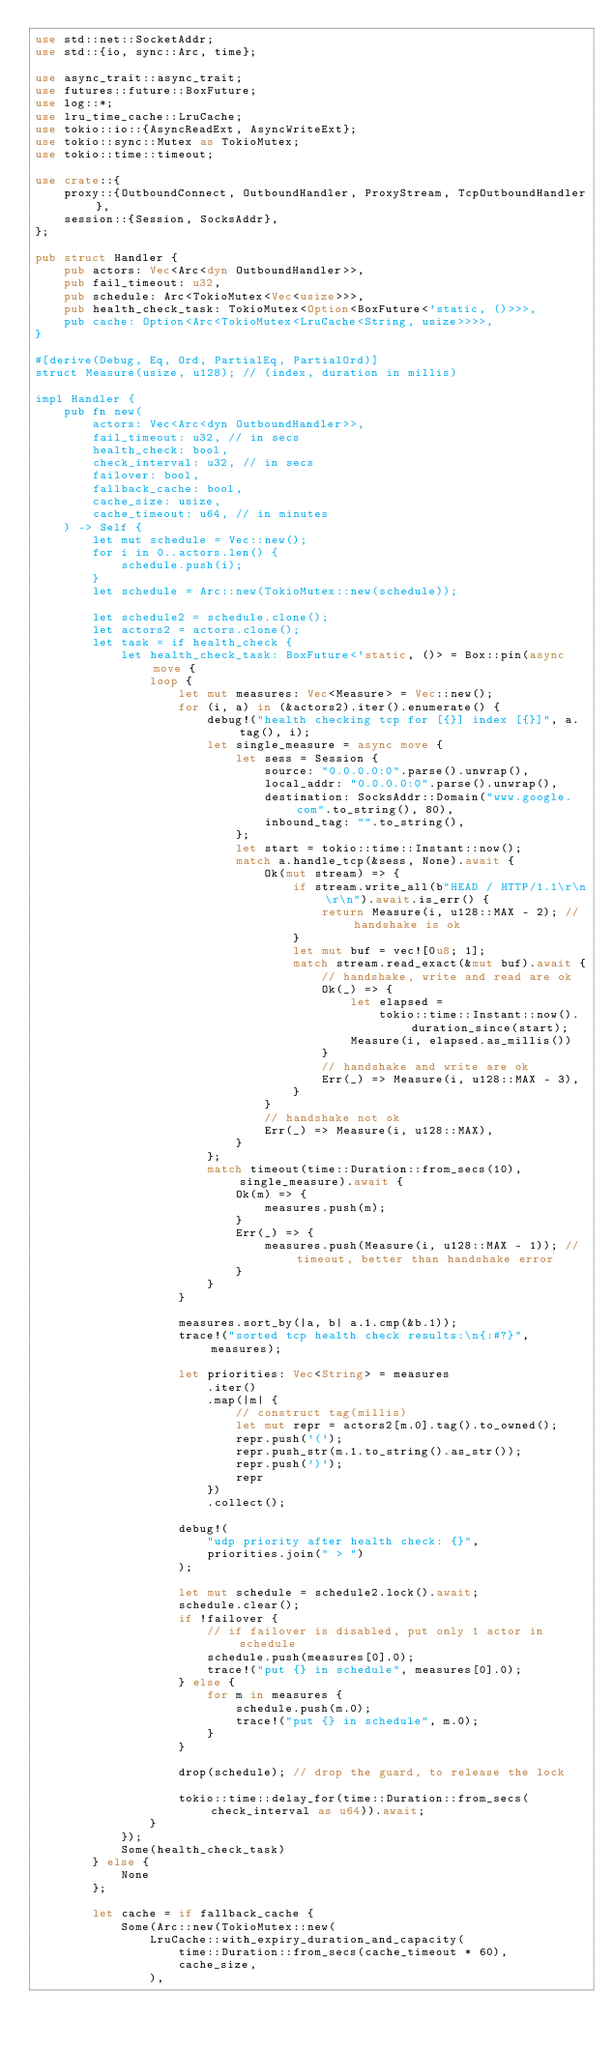Convert code to text. <code><loc_0><loc_0><loc_500><loc_500><_Rust_>use std::net::SocketAddr;
use std::{io, sync::Arc, time};

use async_trait::async_trait;
use futures::future::BoxFuture;
use log::*;
use lru_time_cache::LruCache;
use tokio::io::{AsyncReadExt, AsyncWriteExt};
use tokio::sync::Mutex as TokioMutex;
use tokio::time::timeout;

use crate::{
    proxy::{OutboundConnect, OutboundHandler, ProxyStream, TcpOutboundHandler},
    session::{Session, SocksAddr},
};

pub struct Handler {
    pub actors: Vec<Arc<dyn OutboundHandler>>,
    pub fail_timeout: u32,
    pub schedule: Arc<TokioMutex<Vec<usize>>>,
    pub health_check_task: TokioMutex<Option<BoxFuture<'static, ()>>>,
    pub cache: Option<Arc<TokioMutex<LruCache<String, usize>>>>,
}

#[derive(Debug, Eq, Ord, PartialEq, PartialOrd)]
struct Measure(usize, u128); // (index, duration in millis)

impl Handler {
    pub fn new(
        actors: Vec<Arc<dyn OutboundHandler>>,
        fail_timeout: u32, // in secs
        health_check: bool,
        check_interval: u32, // in secs
        failover: bool,
        fallback_cache: bool,
        cache_size: usize,
        cache_timeout: u64, // in minutes
    ) -> Self {
        let mut schedule = Vec::new();
        for i in 0..actors.len() {
            schedule.push(i);
        }
        let schedule = Arc::new(TokioMutex::new(schedule));

        let schedule2 = schedule.clone();
        let actors2 = actors.clone();
        let task = if health_check {
            let health_check_task: BoxFuture<'static, ()> = Box::pin(async move {
                loop {
                    let mut measures: Vec<Measure> = Vec::new();
                    for (i, a) in (&actors2).iter().enumerate() {
                        debug!("health checking tcp for [{}] index [{}]", a.tag(), i);
                        let single_measure = async move {
                            let sess = Session {
                                source: "0.0.0.0:0".parse().unwrap(),
                                local_addr: "0.0.0.0:0".parse().unwrap(),
                                destination: SocksAddr::Domain("www.google.com".to_string(), 80),
                                inbound_tag: "".to_string(),
                            };
                            let start = tokio::time::Instant::now();
                            match a.handle_tcp(&sess, None).await {
                                Ok(mut stream) => {
                                    if stream.write_all(b"HEAD / HTTP/1.1\r\n\r\n").await.is_err() {
                                        return Measure(i, u128::MAX - 2); // handshake is ok
                                    }
                                    let mut buf = vec![0u8; 1];
                                    match stream.read_exact(&mut buf).await {
                                        // handshake, write and read are ok
                                        Ok(_) => {
                                            let elapsed =
                                                tokio::time::Instant::now().duration_since(start);
                                            Measure(i, elapsed.as_millis())
                                        }
                                        // handshake and write are ok
                                        Err(_) => Measure(i, u128::MAX - 3),
                                    }
                                }
                                // handshake not ok
                                Err(_) => Measure(i, u128::MAX),
                            }
                        };
                        match timeout(time::Duration::from_secs(10), single_measure).await {
                            Ok(m) => {
                                measures.push(m);
                            }
                            Err(_) => {
                                measures.push(Measure(i, u128::MAX - 1)); // timeout, better than handshake error
                            }
                        }
                    }

                    measures.sort_by(|a, b| a.1.cmp(&b.1));
                    trace!("sorted tcp health check results:\n{:#?}", measures);

                    let priorities: Vec<String> = measures
                        .iter()
                        .map(|m| {
                            // construct tag(millis)
                            let mut repr = actors2[m.0].tag().to_owned();
                            repr.push('(');
                            repr.push_str(m.1.to_string().as_str());
                            repr.push(')');
                            repr
                        })
                        .collect();

                    debug!(
                        "udp priority after health check: {}",
                        priorities.join(" > ")
                    );

                    let mut schedule = schedule2.lock().await;
                    schedule.clear();
                    if !failover {
                        // if failover is disabled, put only 1 actor in schedule
                        schedule.push(measures[0].0);
                        trace!("put {} in schedule", measures[0].0);
                    } else {
                        for m in measures {
                            schedule.push(m.0);
                            trace!("put {} in schedule", m.0);
                        }
                    }

                    drop(schedule); // drop the guard, to release the lock

                    tokio::time::delay_for(time::Duration::from_secs(check_interval as u64)).await;
                }
            });
            Some(health_check_task)
        } else {
            None
        };

        let cache = if fallback_cache {
            Some(Arc::new(TokioMutex::new(
                LruCache::with_expiry_duration_and_capacity(
                    time::Duration::from_secs(cache_timeout * 60),
                    cache_size,
                ),</code> 